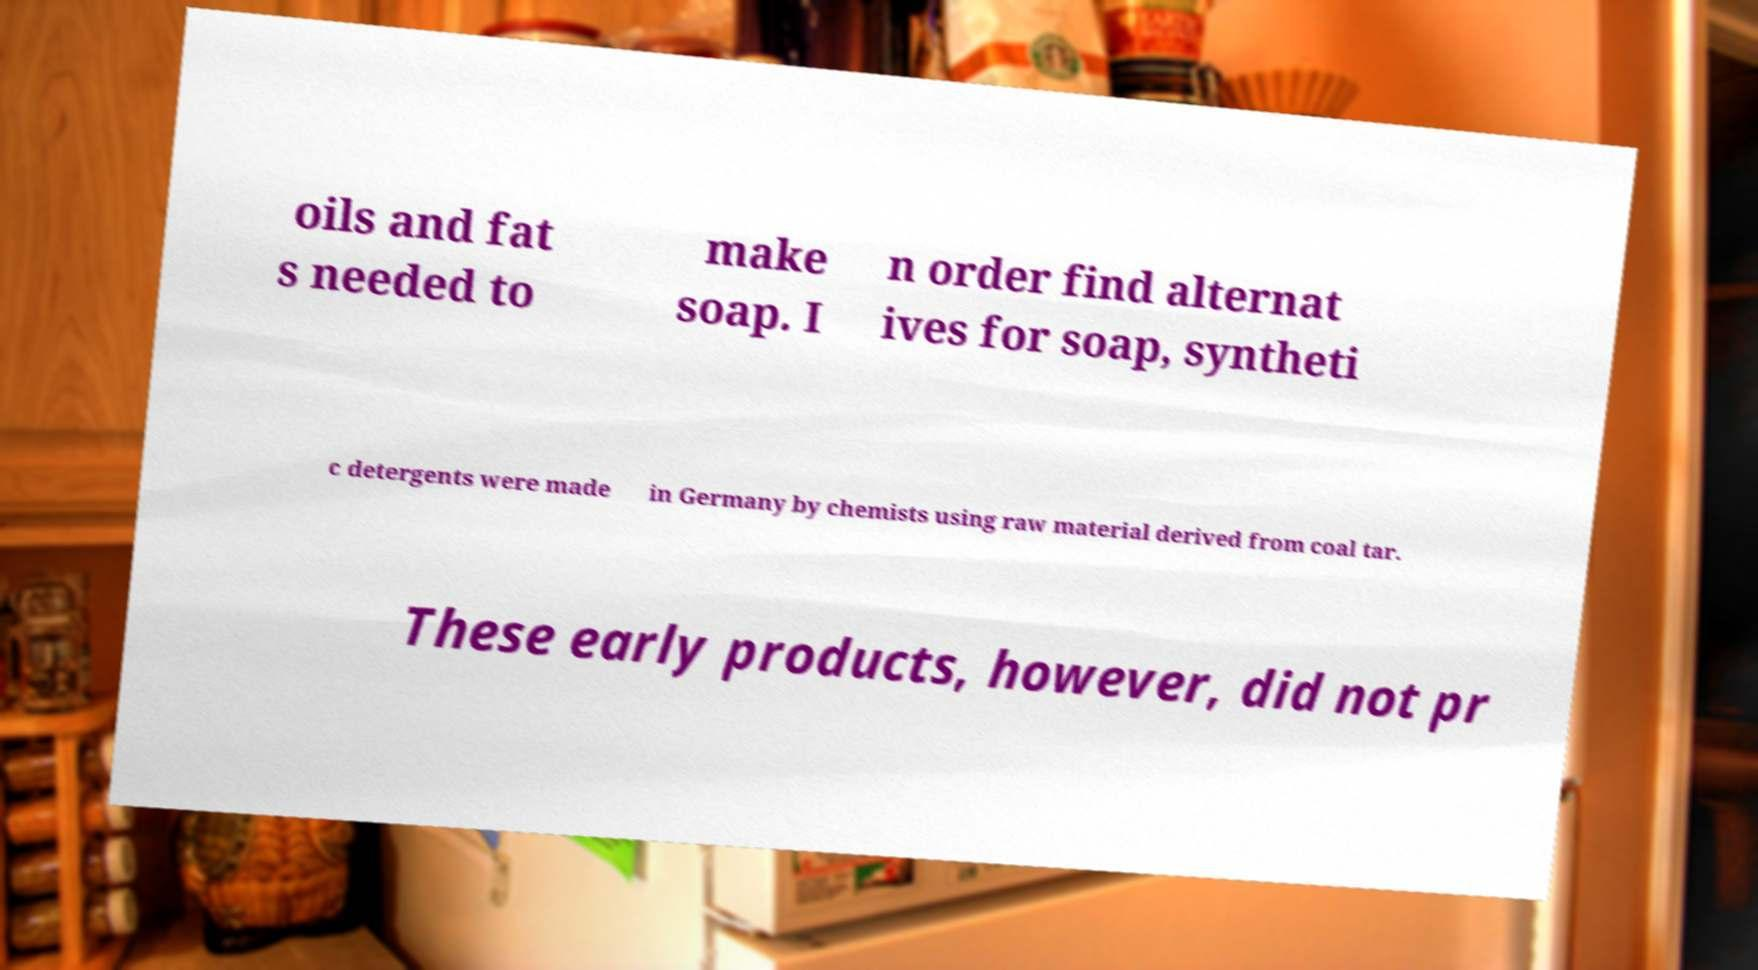There's text embedded in this image that I need extracted. Can you transcribe it verbatim? oils and fat s needed to make soap. I n order find alternat ives for soap, syntheti c detergents were made in Germany by chemists using raw material derived from coal tar. These early products, however, did not pr 